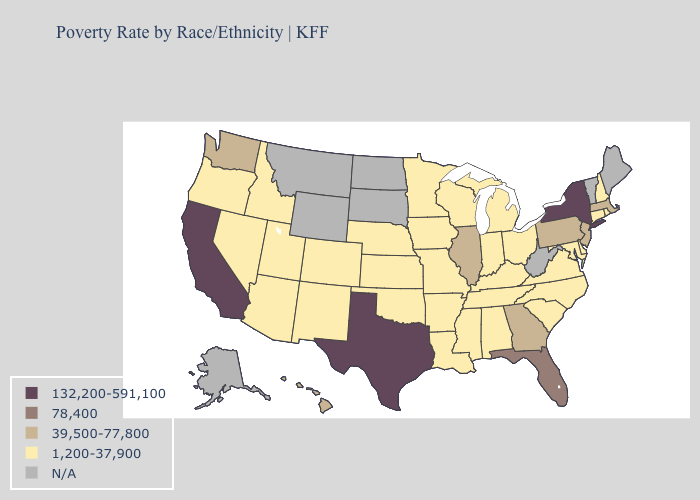Among the states that border Tennessee , does Virginia have the highest value?
Write a very short answer. No. Which states have the lowest value in the USA?
Short answer required. Alabama, Arizona, Arkansas, Colorado, Connecticut, Delaware, Idaho, Indiana, Iowa, Kansas, Kentucky, Louisiana, Maryland, Michigan, Minnesota, Mississippi, Missouri, Nebraska, Nevada, New Hampshire, New Mexico, North Carolina, Ohio, Oklahoma, Oregon, Rhode Island, South Carolina, Tennessee, Utah, Virginia, Wisconsin. Among the states that border Wisconsin , does Minnesota have the lowest value?
Quick response, please. Yes. Name the states that have a value in the range 1,200-37,900?
Be succinct. Alabama, Arizona, Arkansas, Colorado, Connecticut, Delaware, Idaho, Indiana, Iowa, Kansas, Kentucky, Louisiana, Maryland, Michigan, Minnesota, Mississippi, Missouri, Nebraska, Nevada, New Hampshire, New Mexico, North Carolina, Ohio, Oklahoma, Oregon, Rhode Island, South Carolina, Tennessee, Utah, Virginia, Wisconsin. Name the states that have a value in the range 132,200-591,100?
Short answer required. California, New York, Texas. Is the legend a continuous bar?
Short answer required. No. What is the highest value in the USA?
Quick response, please. 132,200-591,100. Among the states that border Michigan , which have the lowest value?
Keep it brief. Indiana, Ohio, Wisconsin. Name the states that have a value in the range N/A?
Be succinct. Alaska, Maine, Montana, North Dakota, South Dakota, Vermont, West Virginia, Wyoming. Among the states that border Arkansas , which have the lowest value?
Write a very short answer. Louisiana, Mississippi, Missouri, Oklahoma, Tennessee. How many symbols are there in the legend?
Give a very brief answer. 5. Which states have the highest value in the USA?
Short answer required. California, New York, Texas. How many symbols are there in the legend?
Short answer required. 5. 